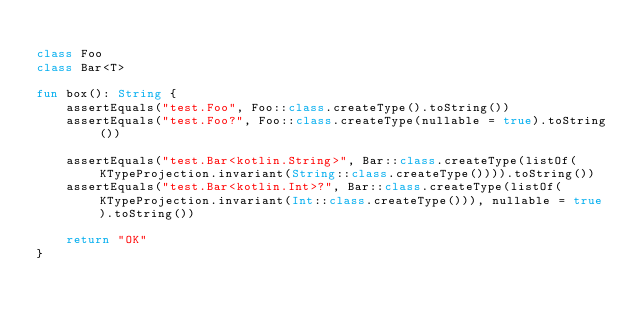<code> <loc_0><loc_0><loc_500><loc_500><_Kotlin_>
class Foo
class Bar<T>

fun box(): String {
    assertEquals("test.Foo", Foo::class.createType().toString())
    assertEquals("test.Foo?", Foo::class.createType(nullable = true).toString())

    assertEquals("test.Bar<kotlin.String>", Bar::class.createType(listOf(KTypeProjection.invariant(String::class.createType()))).toString())
    assertEquals("test.Bar<kotlin.Int>?", Bar::class.createType(listOf(KTypeProjection.invariant(Int::class.createType())), nullable = true).toString())

    return "OK"
}
</code> 